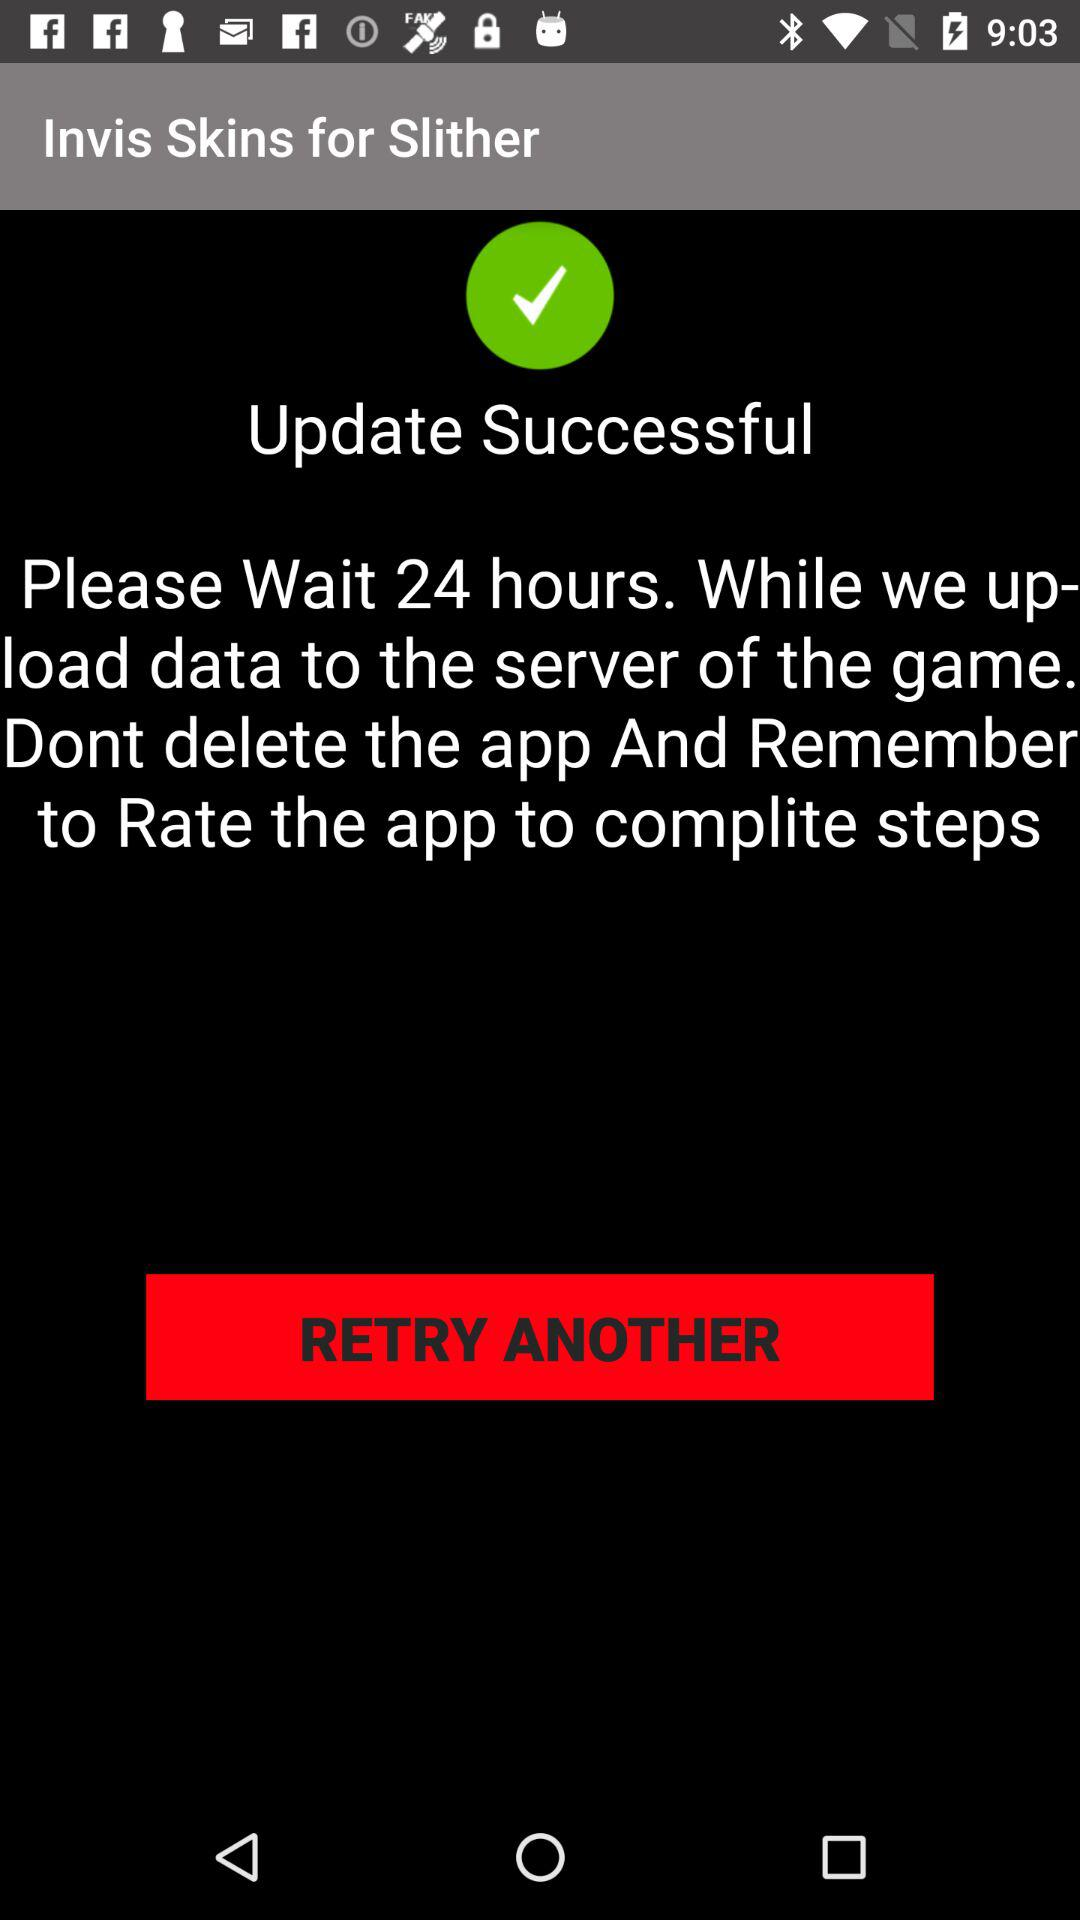How many more hours do I have to wait until I can play the game?
Answer the question using a single word or phrase. 24 